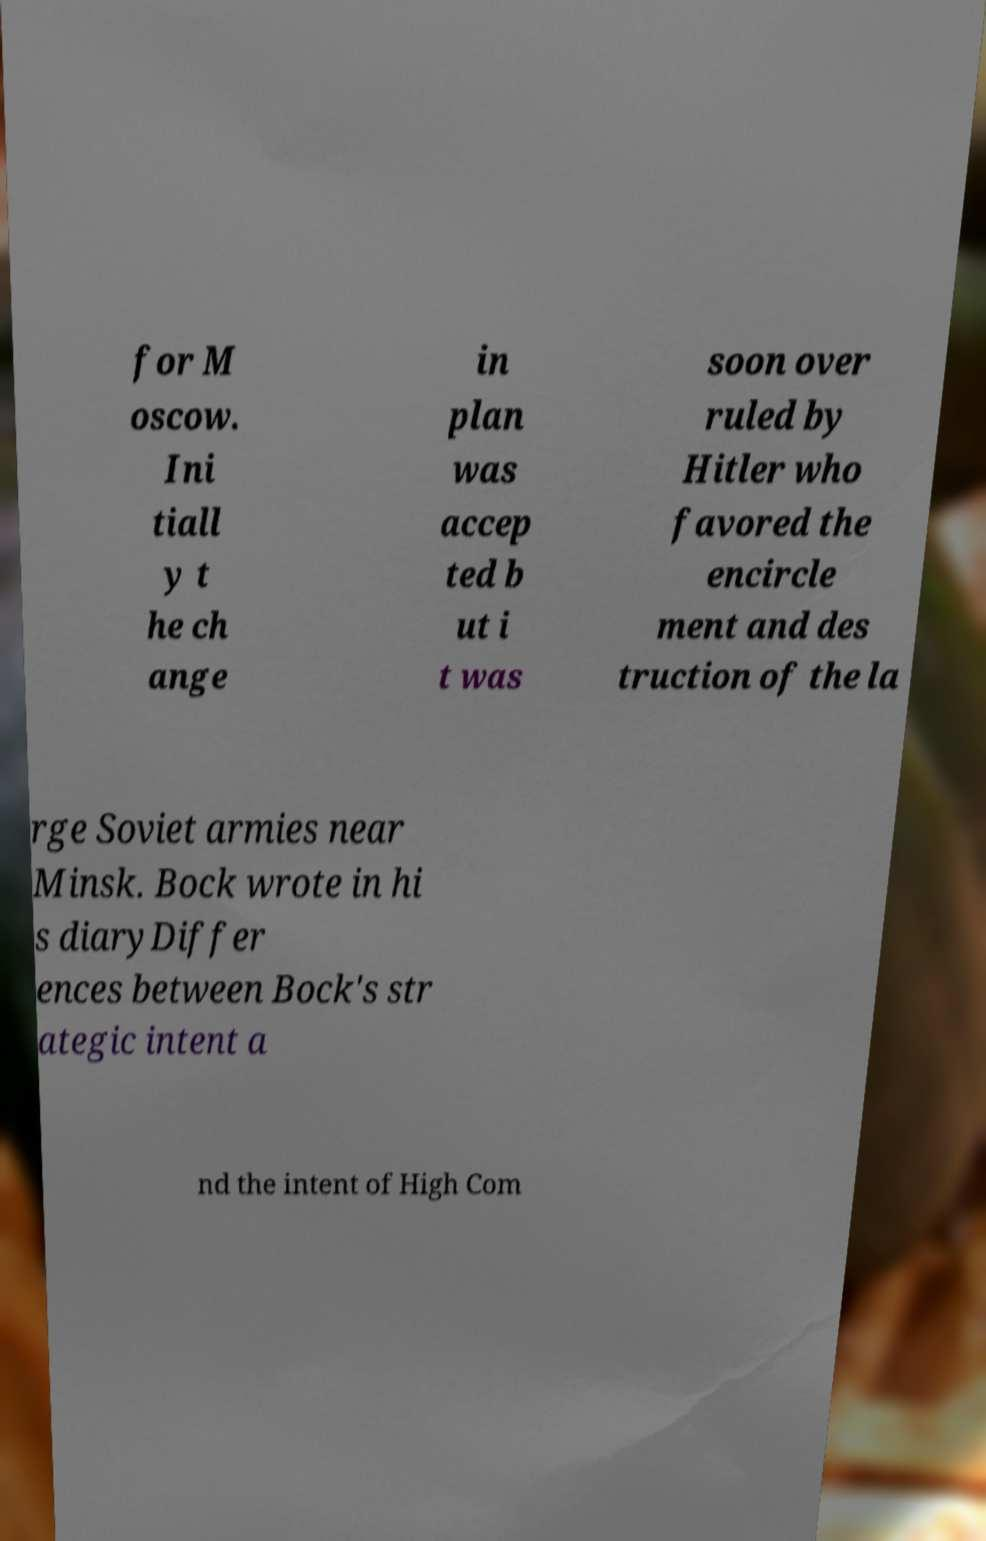Please identify and transcribe the text found in this image. for M oscow. Ini tiall y t he ch ange in plan was accep ted b ut i t was soon over ruled by Hitler who favored the encircle ment and des truction of the la rge Soviet armies near Minsk. Bock wrote in hi s diaryDiffer ences between Bock's str ategic intent a nd the intent of High Com 